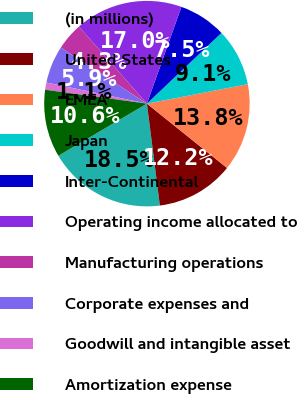Convert chart to OTSL. <chart><loc_0><loc_0><loc_500><loc_500><pie_chart><fcel>(in millions)<fcel>United States<fcel>EMEA<fcel>Japan<fcel>Inter-Continental<fcel>Operating income allocated to<fcel>Manufacturing operations<fcel>Corporate expenses and<fcel>Goodwill and intangible asset<fcel>Amortization expense<nl><fcel>18.54%<fcel>12.22%<fcel>13.8%<fcel>9.05%<fcel>7.47%<fcel>16.96%<fcel>4.3%<fcel>5.89%<fcel>1.14%<fcel>10.63%<nl></chart> 